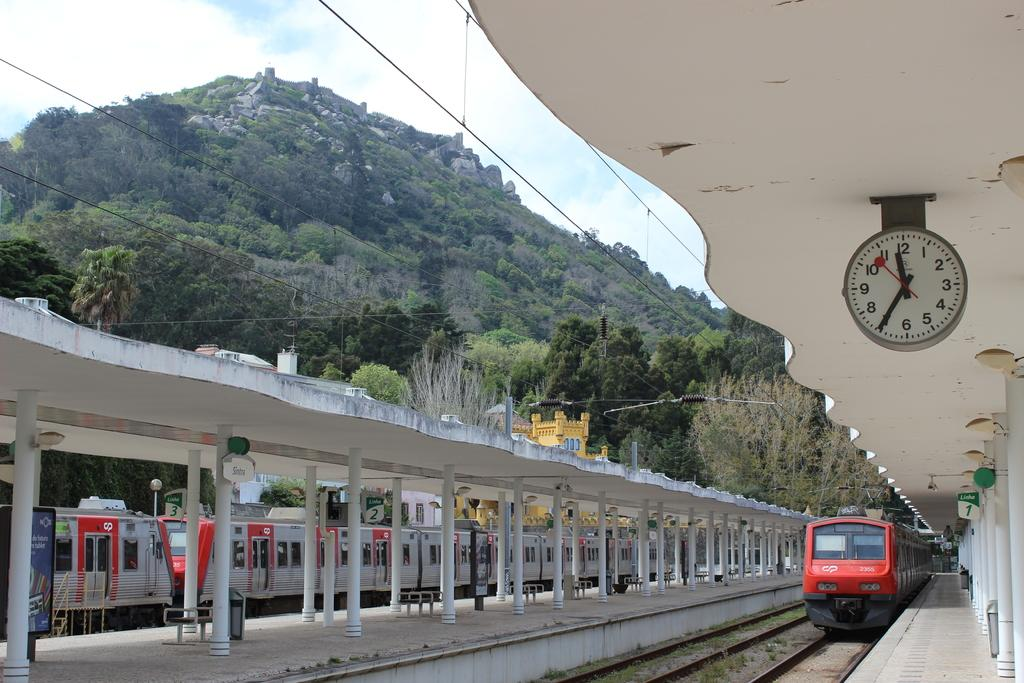<image>
Summarize the visual content of the image. A clock tells the time of 11:35 am at a train station. 